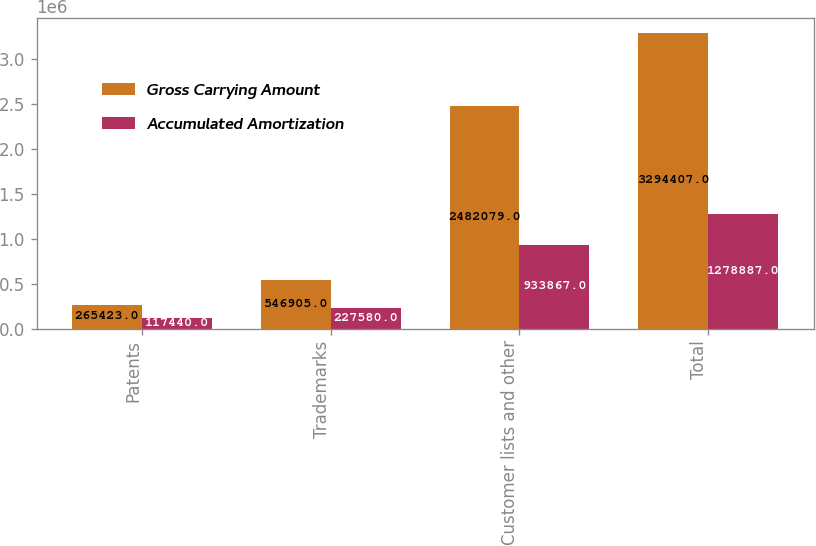Convert chart. <chart><loc_0><loc_0><loc_500><loc_500><stacked_bar_chart><ecel><fcel>Patents<fcel>Trademarks<fcel>Customer lists and other<fcel>Total<nl><fcel>Gross Carrying Amount<fcel>265423<fcel>546905<fcel>2.48208e+06<fcel>3.29441e+06<nl><fcel>Accumulated Amortization<fcel>117440<fcel>227580<fcel>933867<fcel>1.27889e+06<nl></chart> 